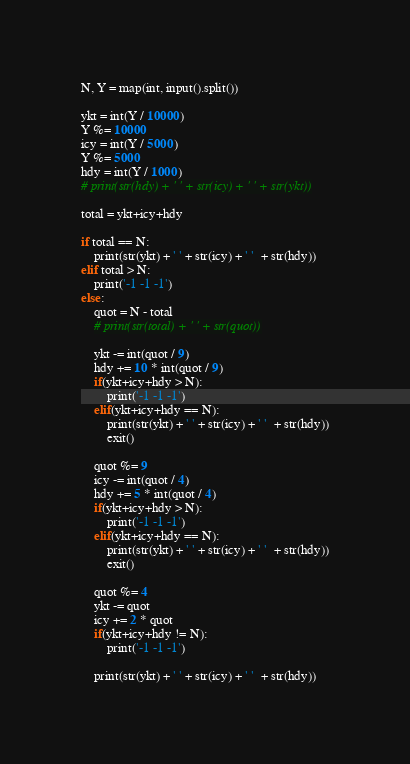<code> <loc_0><loc_0><loc_500><loc_500><_Python_>N, Y = map(int, input().split())

ykt = int(Y / 10000)
Y %= 10000
icy = int(Y / 5000)
Y %= 5000
hdy = int(Y / 1000)
# print(str(hdy) + ' ' + str(icy) + ' ' + str(ykt))

total = ykt+icy+hdy

if total == N:
    print(str(ykt) + ' ' + str(icy) + ' '  + str(hdy))
elif total > N:
    print('-1 -1 -1')
else:
    quot = N - total
    # print(str(total) + ' ' + str(quot))

    ykt -= int(quot / 9)
    hdy += 10 * int(quot / 9)
    if(ykt+icy+hdy > N):
        print('-1 -1 -1')
    elif(ykt+icy+hdy == N):
        print(str(ykt) + ' ' + str(icy) + ' '  + str(hdy))
        exit()

    quot %= 9
    icy -= int(quot / 4)
    hdy += 5 * int(quot / 4)
    if(ykt+icy+hdy > N):
        print('-1 -1 -1')
    elif(ykt+icy+hdy == N):
        print(str(ykt) + ' ' + str(icy) + ' '  + str(hdy))
        exit()

    quot %= 4
    ykt -= quot
    icy += 2 * quot
    if(ykt+icy+hdy != N):
        print('-1 -1 -1')

    print(str(ykt) + ' ' + str(icy) + ' '  + str(hdy))

</code> 